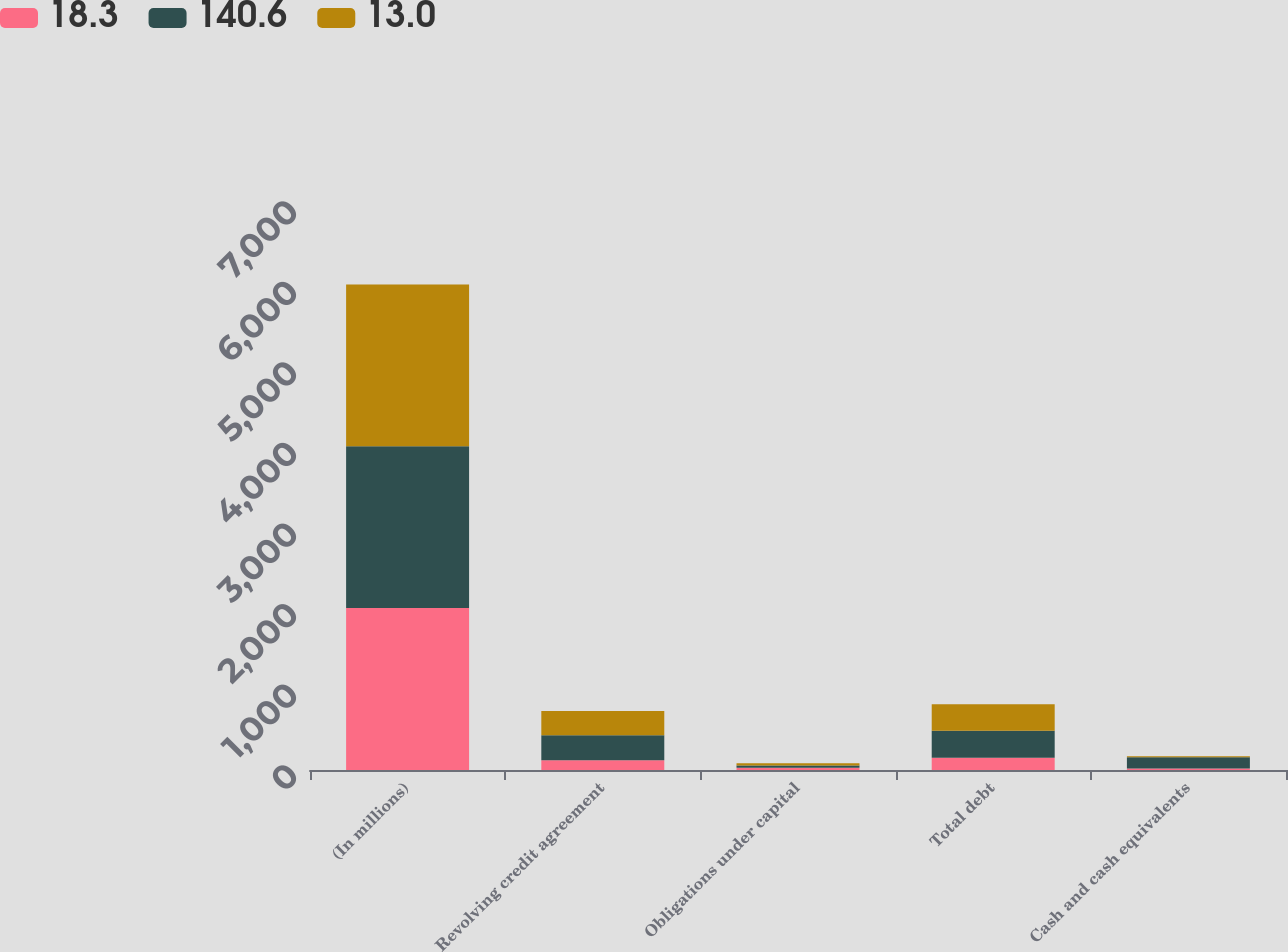Convert chart. <chart><loc_0><loc_0><loc_500><loc_500><stacked_bar_chart><ecel><fcel>(In millions)<fcel>Revolving credit agreement<fcel>Obligations under capital<fcel>Total debt<fcel>Cash and cash equivalents<nl><fcel>18.3<fcel>2010<fcel>122.5<fcel>28.1<fcel>150.6<fcel>18.3<nl><fcel>140.6<fcel>2009<fcel>308.5<fcel>28.6<fcel>337<fcel>140.6<nl><fcel>13<fcel>2008<fcel>300.2<fcel>27.6<fcel>327.8<fcel>13<nl></chart> 